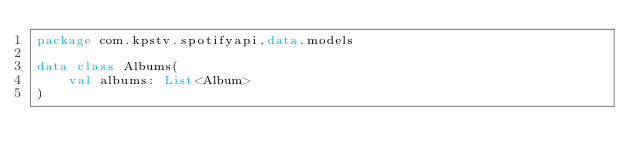<code> <loc_0><loc_0><loc_500><loc_500><_Kotlin_>package com.kpstv.spotifyapi.data.models

data class Albums(
    val albums: List<Album>
)</code> 